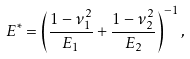Convert formula to latex. <formula><loc_0><loc_0><loc_500><loc_500>E ^ { \ast } = \left ( \frac { 1 - \nu _ { 1 } ^ { 2 } } { E _ { 1 } } + \frac { 1 - \nu _ { 2 } ^ { 2 } } { E _ { 2 } } \right ) ^ { - 1 } , \label H { e q \colon e l a s t i c i t y }</formula> 